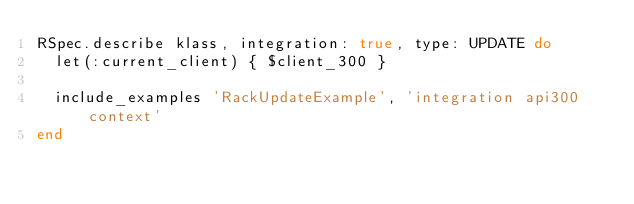<code> <loc_0><loc_0><loc_500><loc_500><_Ruby_>RSpec.describe klass, integration: true, type: UPDATE do
  let(:current_client) { $client_300 }

  include_examples 'RackUpdateExample', 'integration api300 context'
end
</code> 